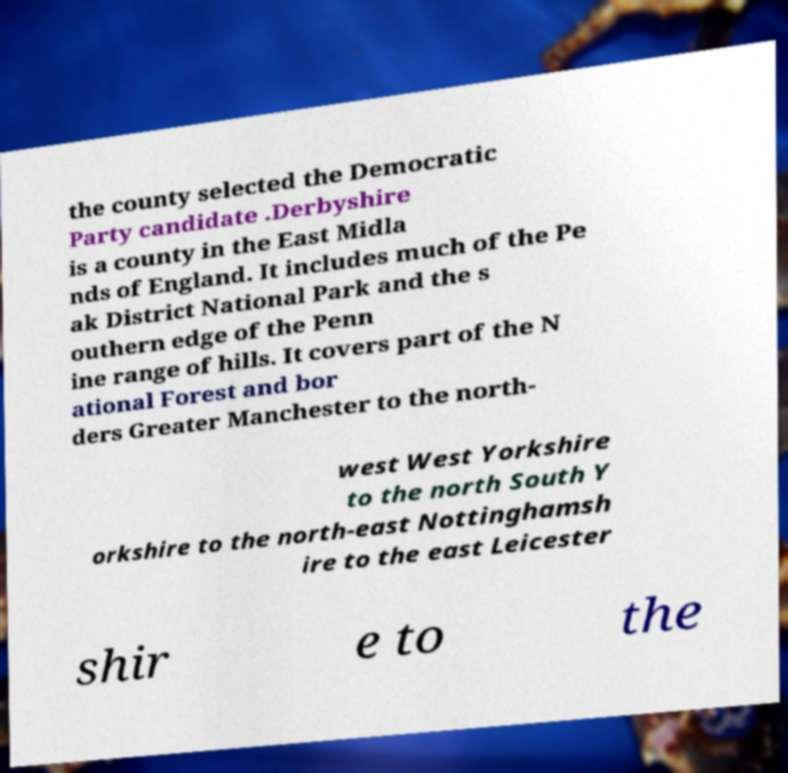Could you extract and type out the text from this image? the county selected the Democratic Party candidate .Derbyshire is a county in the East Midla nds of England. It includes much of the Pe ak District National Park and the s outhern edge of the Penn ine range of hills. It covers part of the N ational Forest and bor ders Greater Manchester to the north- west West Yorkshire to the north South Y orkshire to the north-east Nottinghamsh ire to the east Leicester shir e to the 